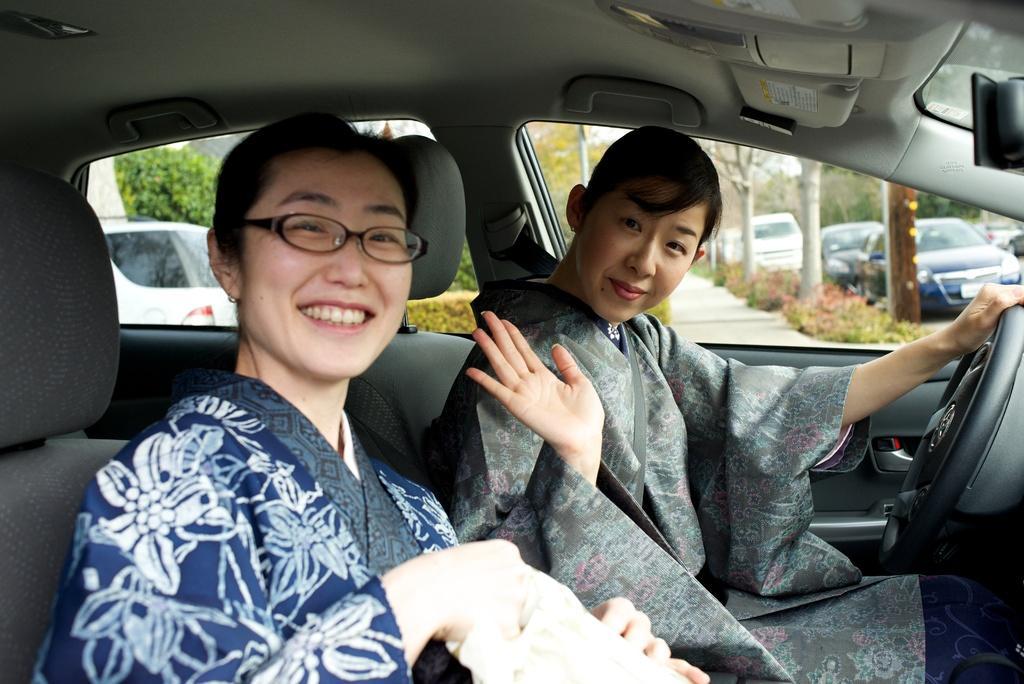How would you summarize this image in a sentence or two? In this picture we see two women with the smile on their face travelling in a car and we see few cars parked along. 